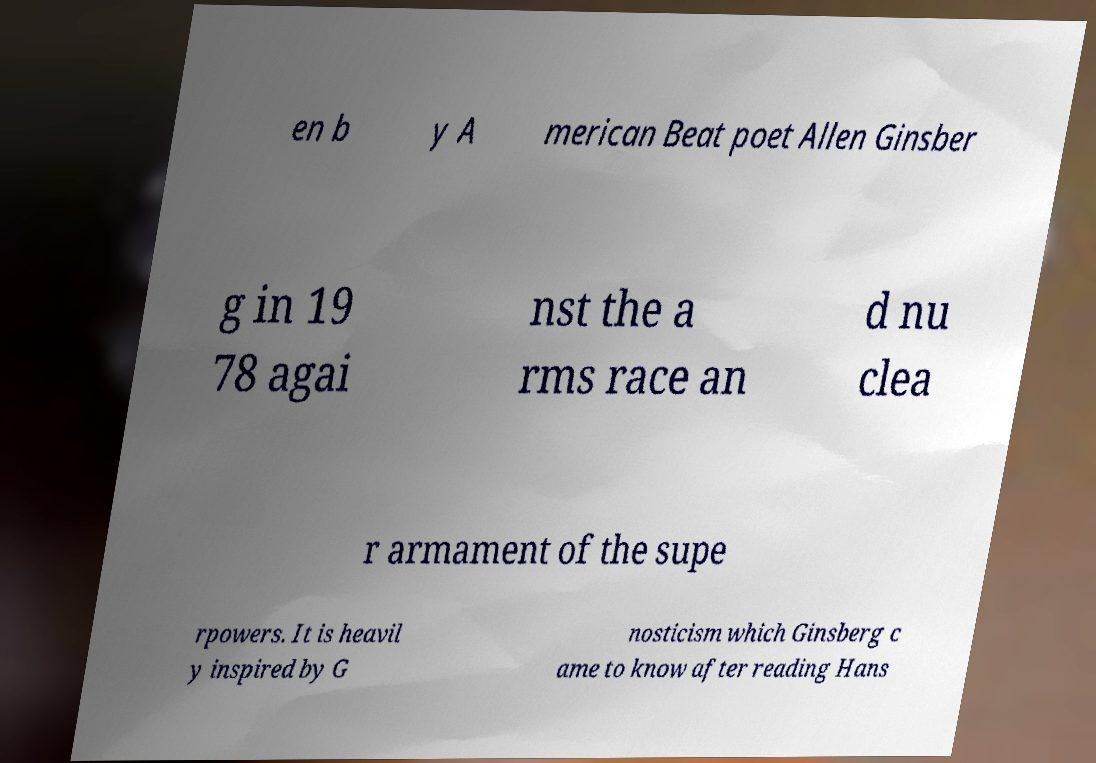Could you assist in decoding the text presented in this image and type it out clearly? en b y A merican Beat poet Allen Ginsber g in 19 78 agai nst the a rms race an d nu clea r armament of the supe rpowers. It is heavil y inspired by G nosticism which Ginsberg c ame to know after reading Hans 